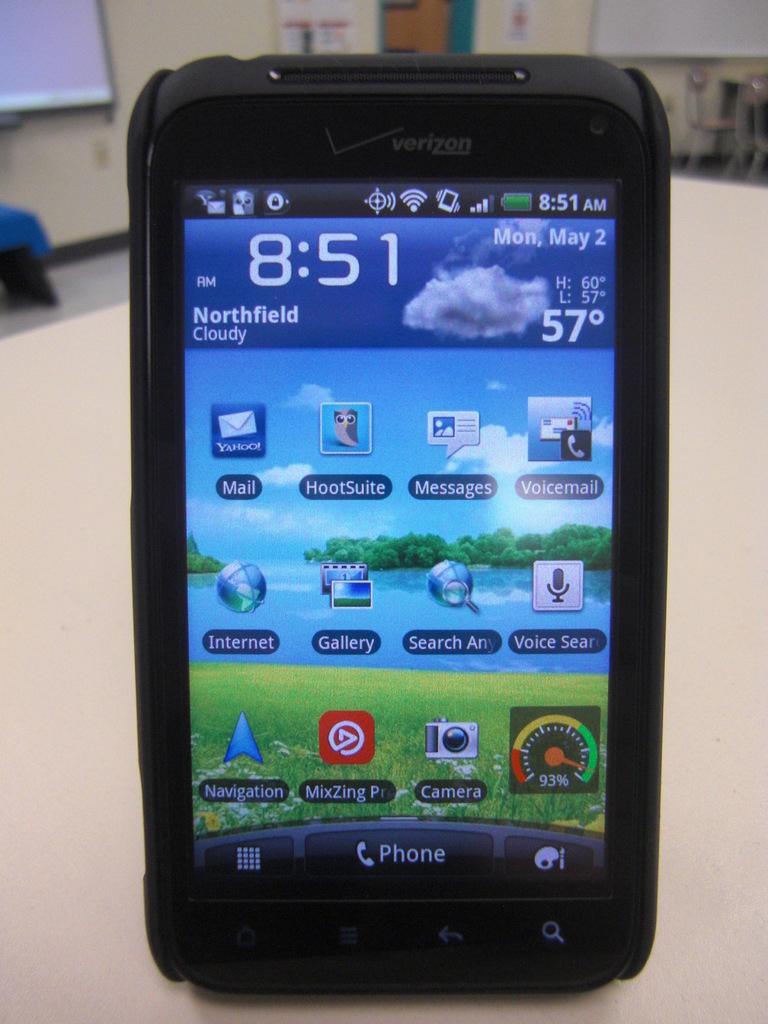What is the temperature?
Your response must be concise. 57 degrees. What time is it?
Your answer should be compact. 8:51. 